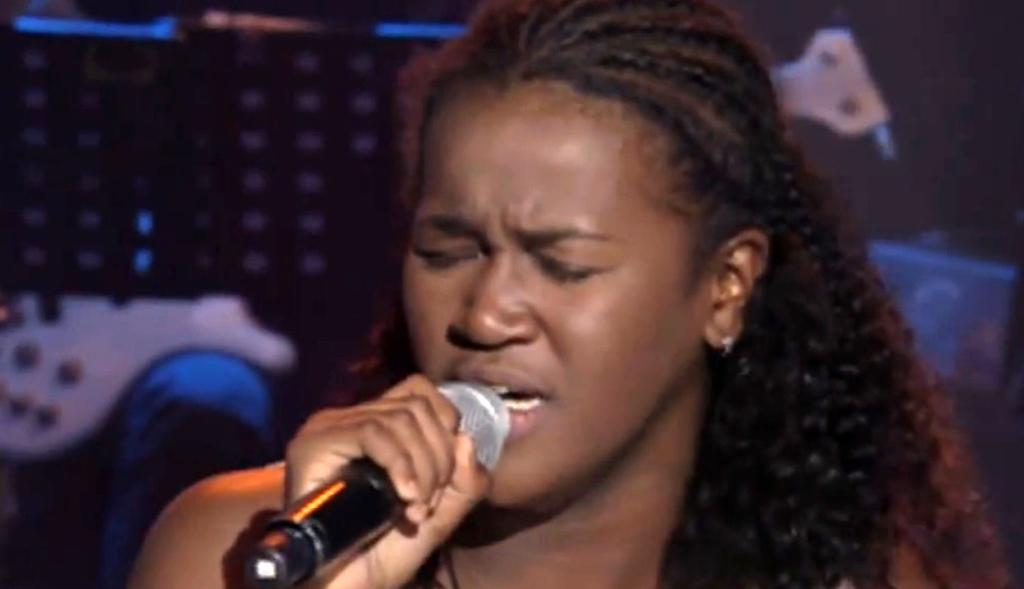Who is the main subject in the image? There is a person in the image. What is the person holding in the image? The person is holding a microphone. What is the person doing in the image? The person is singing. What type of plot is the person standing on in the image? There is no plot present in the image; it is a person holding a microphone and singing. Can you see any notebook or canvas in the image? No, there is no notebook or canvas present in the image. 